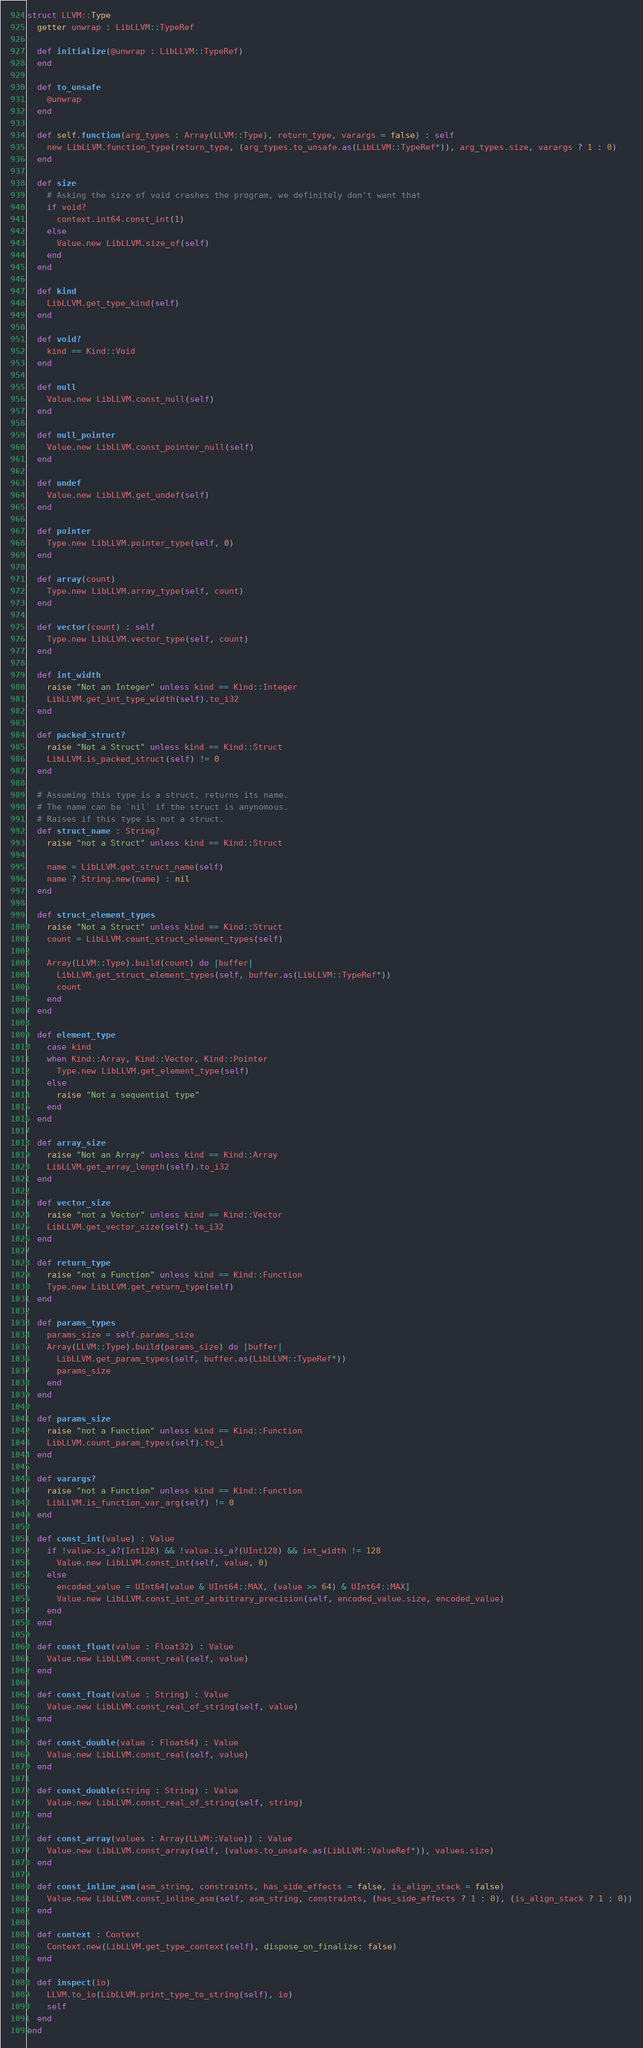Convert code to text. <code><loc_0><loc_0><loc_500><loc_500><_Crystal_>struct LLVM::Type
  getter unwrap : LibLLVM::TypeRef

  def initialize(@unwrap : LibLLVM::TypeRef)
  end

  def to_unsafe
    @unwrap
  end

  def self.function(arg_types : Array(LLVM::Type), return_type, varargs = false) : self
    new LibLLVM.function_type(return_type, (arg_types.to_unsafe.as(LibLLVM::TypeRef*)), arg_types.size, varargs ? 1 : 0)
  end

  def size
    # Asking the size of void crashes the program, we definitely don't want that
    if void?
      context.int64.const_int(1)
    else
      Value.new LibLLVM.size_of(self)
    end
  end

  def kind
    LibLLVM.get_type_kind(self)
  end

  def void?
    kind == Kind::Void
  end

  def null
    Value.new LibLLVM.const_null(self)
  end

  def null_pointer
    Value.new LibLLVM.const_pointer_null(self)
  end

  def undef
    Value.new LibLLVM.get_undef(self)
  end

  def pointer
    Type.new LibLLVM.pointer_type(self, 0)
  end

  def array(count)
    Type.new LibLLVM.array_type(self, count)
  end

  def vector(count) : self
    Type.new LibLLVM.vector_type(self, count)
  end

  def int_width
    raise "Not an Integer" unless kind == Kind::Integer
    LibLLVM.get_int_type_width(self).to_i32
  end

  def packed_struct?
    raise "Not a Struct" unless kind == Kind::Struct
    LibLLVM.is_packed_struct(self) != 0
  end

  # Assuming this type is a struct, returns its name.
  # The name can be `nil` if the struct is anynomous.
  # Raises if this type is not a struct.
  def struct_name : String?
    raise "not a Struct" unless kind == Kind::Struct

    name = LibLLVM.get_struct_name(self)
    name ? String.new(name) : nil
  end

  def struct_element_types
    raise "Not a Struct" unless kind == Kind::Struct
    count = LibLLVM.count_struct_element_types(self)

    Array(LLVM::Type).build(count) do |buffer|
      LibLLVM.get_struct_element_types(self, buffer.as(LibLLVM::TypeRef*))
      count
    end
  end

  def element_type
    case kind
    when Kind::Array, Kind::Vector, Kind::Pointer
      Type.new LibLLVM.get_element_type(self)
    else
      raise "Not a sequential type"
    end
  end

  def array_size
    raise "Not an Array" unless kind == Kind::Array
    LibLLVM.get_array_length(self).to_i32
  end

  def vector_size
    raise "not a Vector" unless kind == Kind::Vector
    LibLLVM.get_vector_size(self).to_i32
  end

  def return_type
    raise "not a Function" unless kind == Kind::Function
    Type.new LibLLVM.get_return_type(self)
  end

  def params_types
    params_size = self.params_size
    Array(LLVM::Type).build(params_size) do |buffer|
      LibLLVM.get_param_types(self, buffer.as(LibLLVM::TypeRef*))
      params_size
    end
  end

  def params_size
    raise "not a Function" unless kind == Kind::Function
    LibLLVM.count_param_types(self).to_i
  end

  def varargs?
    raise "not a Function" unless kind == Kind::Function
    LibLLVM.is_function_var_arg(self) != 0
  end

  def const_int(value) : Value
    if !value.is_a?(Int128) && !value.is_a?(UInt128) && int_width != 128
      Value.new LibLLVM.const_int(self, value, 0)
    else
      encoded_value = UInt64[value & UInt64::MAX, (value >> 64) & UInt64::MAX]
      Value.new LibLLVM.const_int_of_arbitrary_precision(self, encoded_value.size, encoded_value)
    end
  end

  def const_float(value : Float32) : Value
    Value.new LibLLVM.const_real(self, value)
  end

  def const_float(value : String) : Value
    Value.new LibLLVM.const_real_of_string(self, value)
  end

  def const_double(value : Float64) : Value
    Value.new LibLLVM.const_real(self, value)
  end

  def const_double(string : String) : Value
    Value.new LibLLVM.const_real_of_string(self, string)
  end

  def const_array(values : Array(LLVM::Value)) : Value
    Value.new LibLLVM.const_array(self, (values.to_unsafe.as(LibLLVM::ValueRef*)), values.size)
  end

  def const_inline_asm(asm_string, constraints, has_side_effects = false, is_align_stack = false)
    Value.new LibLLVM.const_inline_asm(self, asm_string, constraints, (has_side_effects ? 1 : 0), (is_align_stack ? 1 : 0))
  end

  def context : Context
    Context.new(LibLLVM.get_type_context(self), dispose_on_finalize: false)
  end

  def inspect(io)
    LLVM.to_io(LibLLVM.print_type_to_string(self), io)
    self
  end
end
</code> 